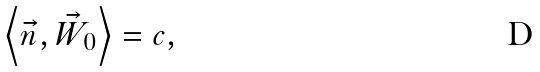<formula> <loc_0><loc_0><loc_500><loc_500>\left \langle \vec { n } , \vec { W } _ { 0 } \right \rangle = c ,</formula> 